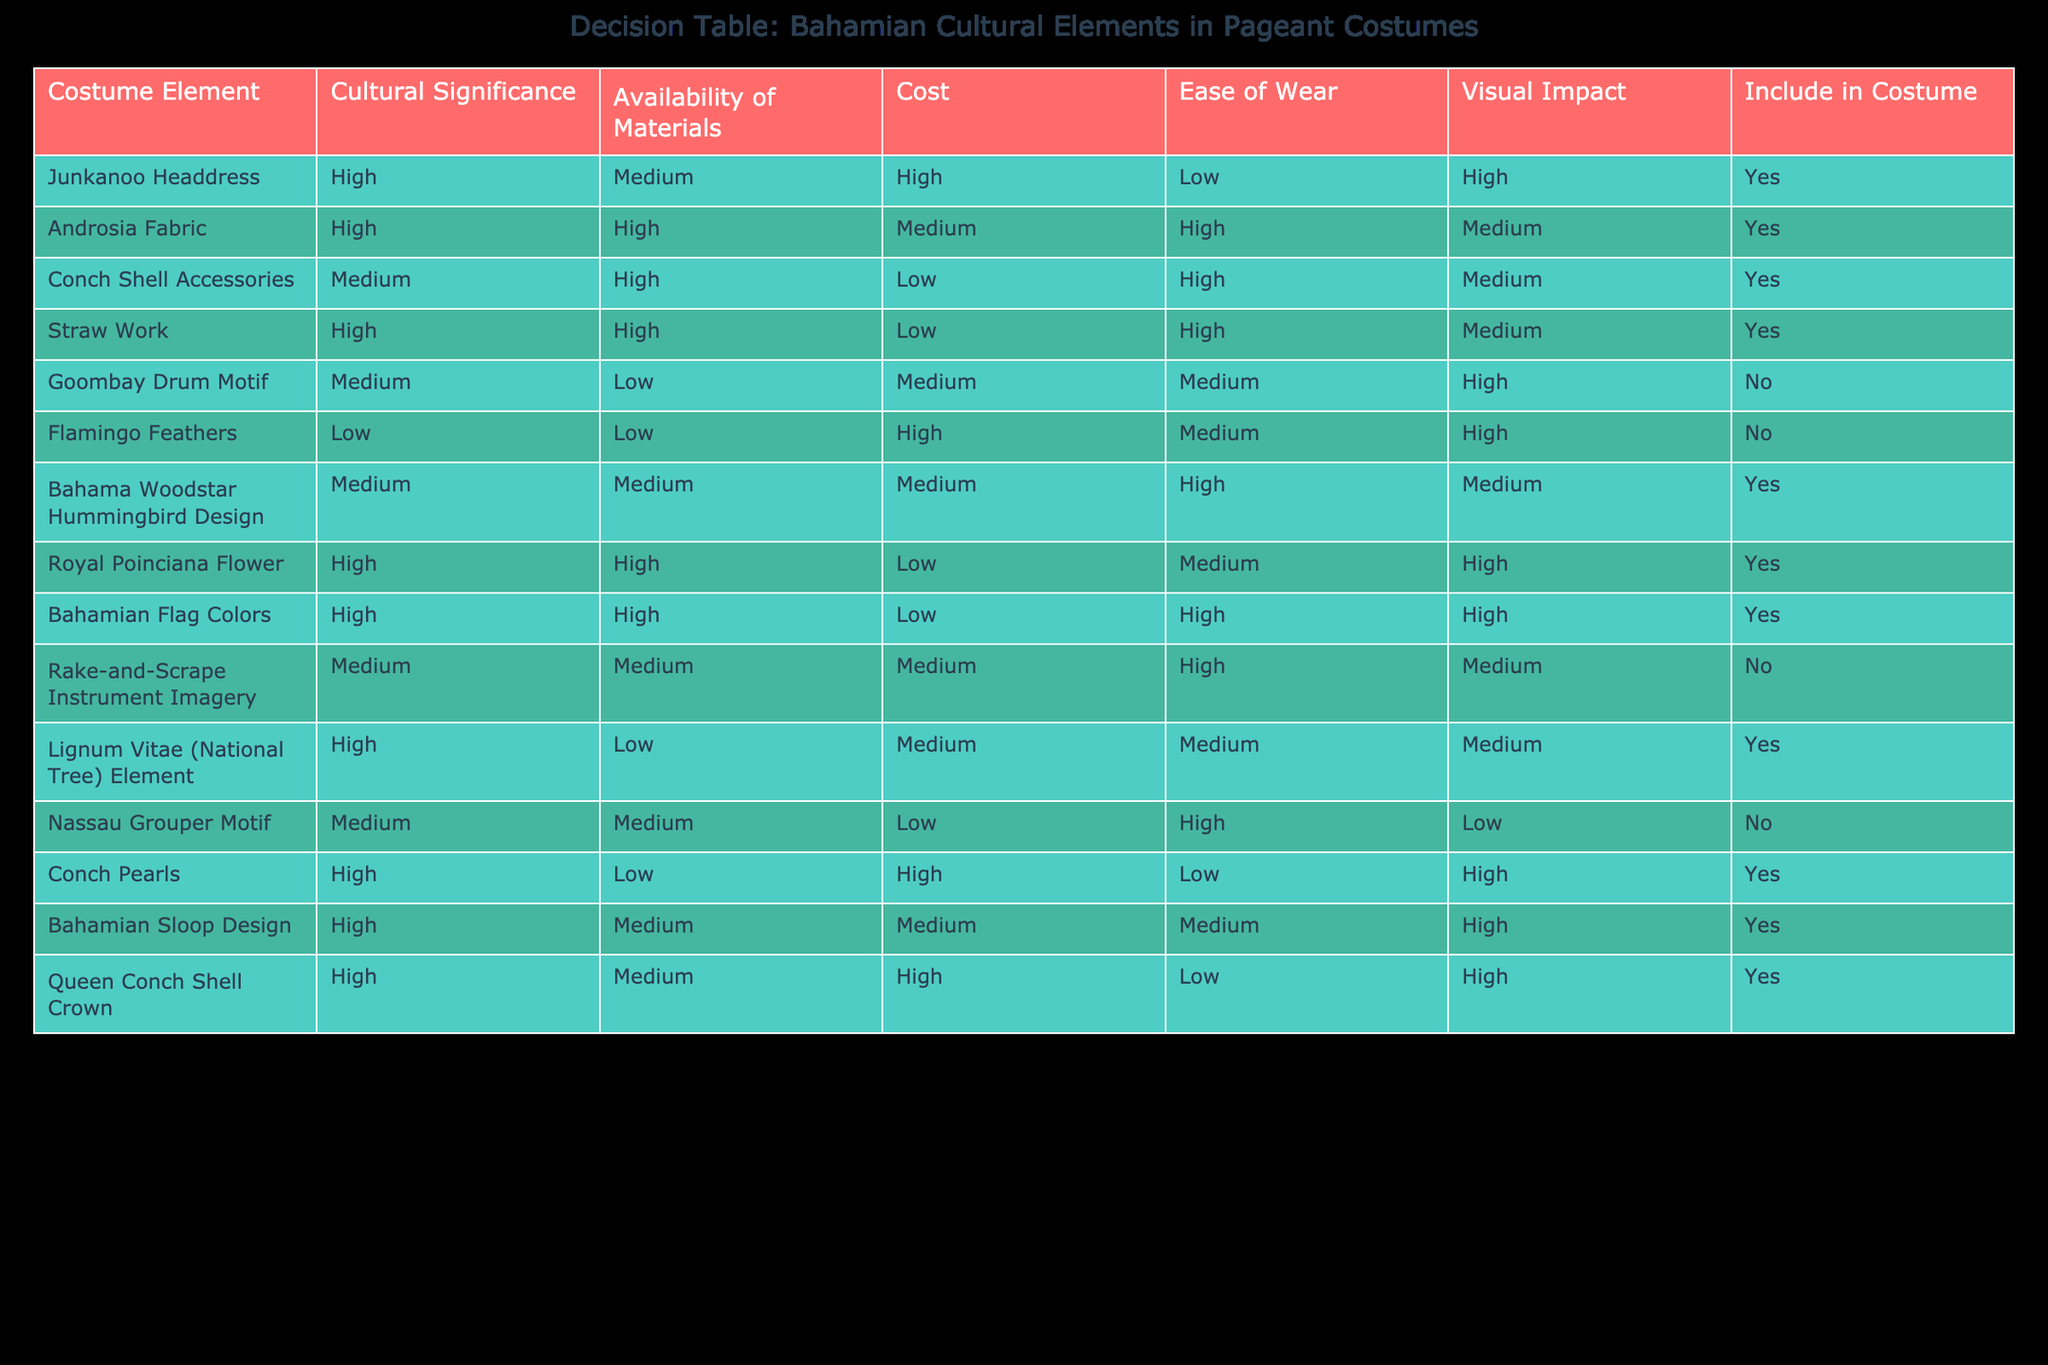What is the cultural significance of the Androsia Fabric? The table indicates that the cultural significance of the Androsia Fabric is classified as high.
Answer: High How many costume elements received a "Yes" for inclusion in the costume? Counting the "Include in Costume" column, there are 8 elements marked as "Yes".
Answer: 8 What are the average costs of the costume elements with high visual impact? The costume elements with high visual impact are Junkanoo Headdress, Bahama Woodstar Hummingbird Design, Royal Poinciana Flower, Bahamian Flag Colors, Conch Pearls, Bahamian Sloop Design, and Queen Conch Shell Crown. Their costs are High (3), Medium (2), Medium (2) - so the average is (High + Medium + Medium + Medium + Medium + High + High) = 3/7 ≈ 2.14, which rounds to Medium.
Answer: Medium Is "Flamingo Feathers" included in the costume? According to the table, Flamingo Feathers is marked as "No" for inclusion in the costume.
Answer: No What is the visual impact of the Straw Work? The table specifies that the visual impact of Straw Work is high.
Answer: High Which costume element has low availability of materials but high cultural significance? The Lignum Vitae (National Tree) Element has high cultural significance but low availability of materials.
Answer: Lignum Vitae (National Tree) Element Count how many costume elements are included that are associated with high cultural significance and high availability of materials. The costume elements with high cultural significance and high availability of materials are Androsia Fabric, Royal Poinciana Flower, and Bahamian Flag Colors, totaling 3 elements.
Answer: 3 Are there any costume elements that have high costs but are not included in the final costume? Yes, there are two elements with high costs (Goombay Drum Motif and Flamingo Feathers) that are not included.
Answer: Yes 